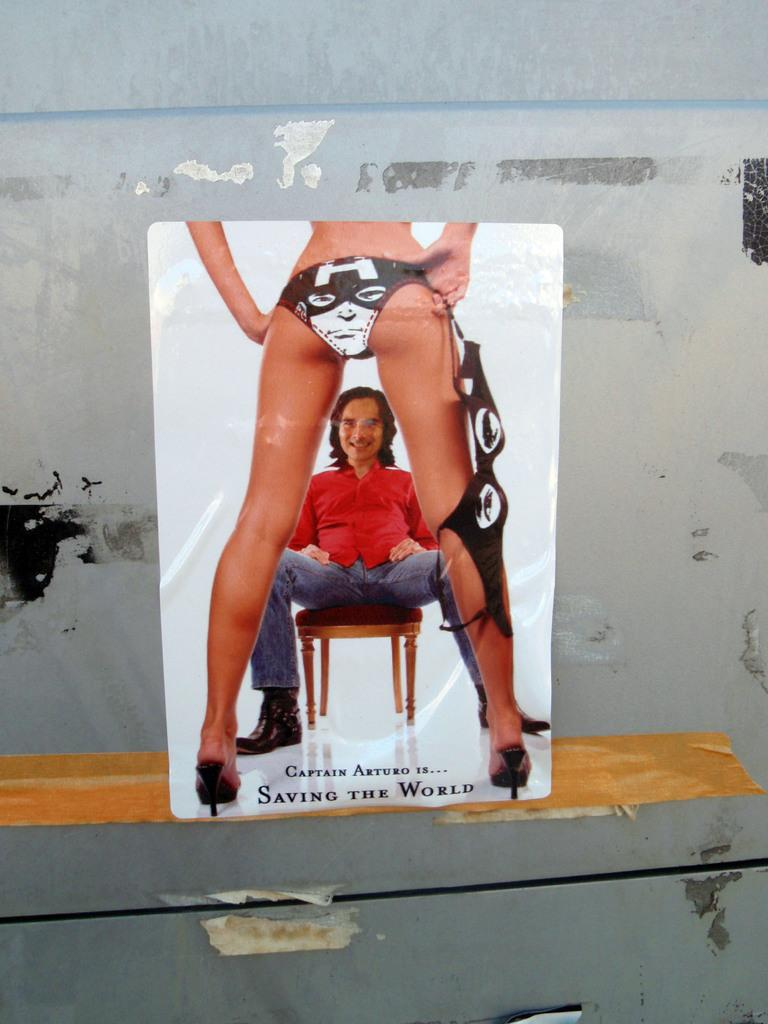What type of medium is the image presented on? The image appears to be a poster. How is the poster displayed or attached? The poster is attached to a board. What is the primary subject of the image? There is a woman standing in the image. Are there any other people in the image? Yes, there is a person sitting on a chair in the image. What can be found on the poster besides the images of people? There are letters on the poster. What type of spark can be seen coming from the machine in the image? There is no machine present in the image, so there is no spark to be observed. 